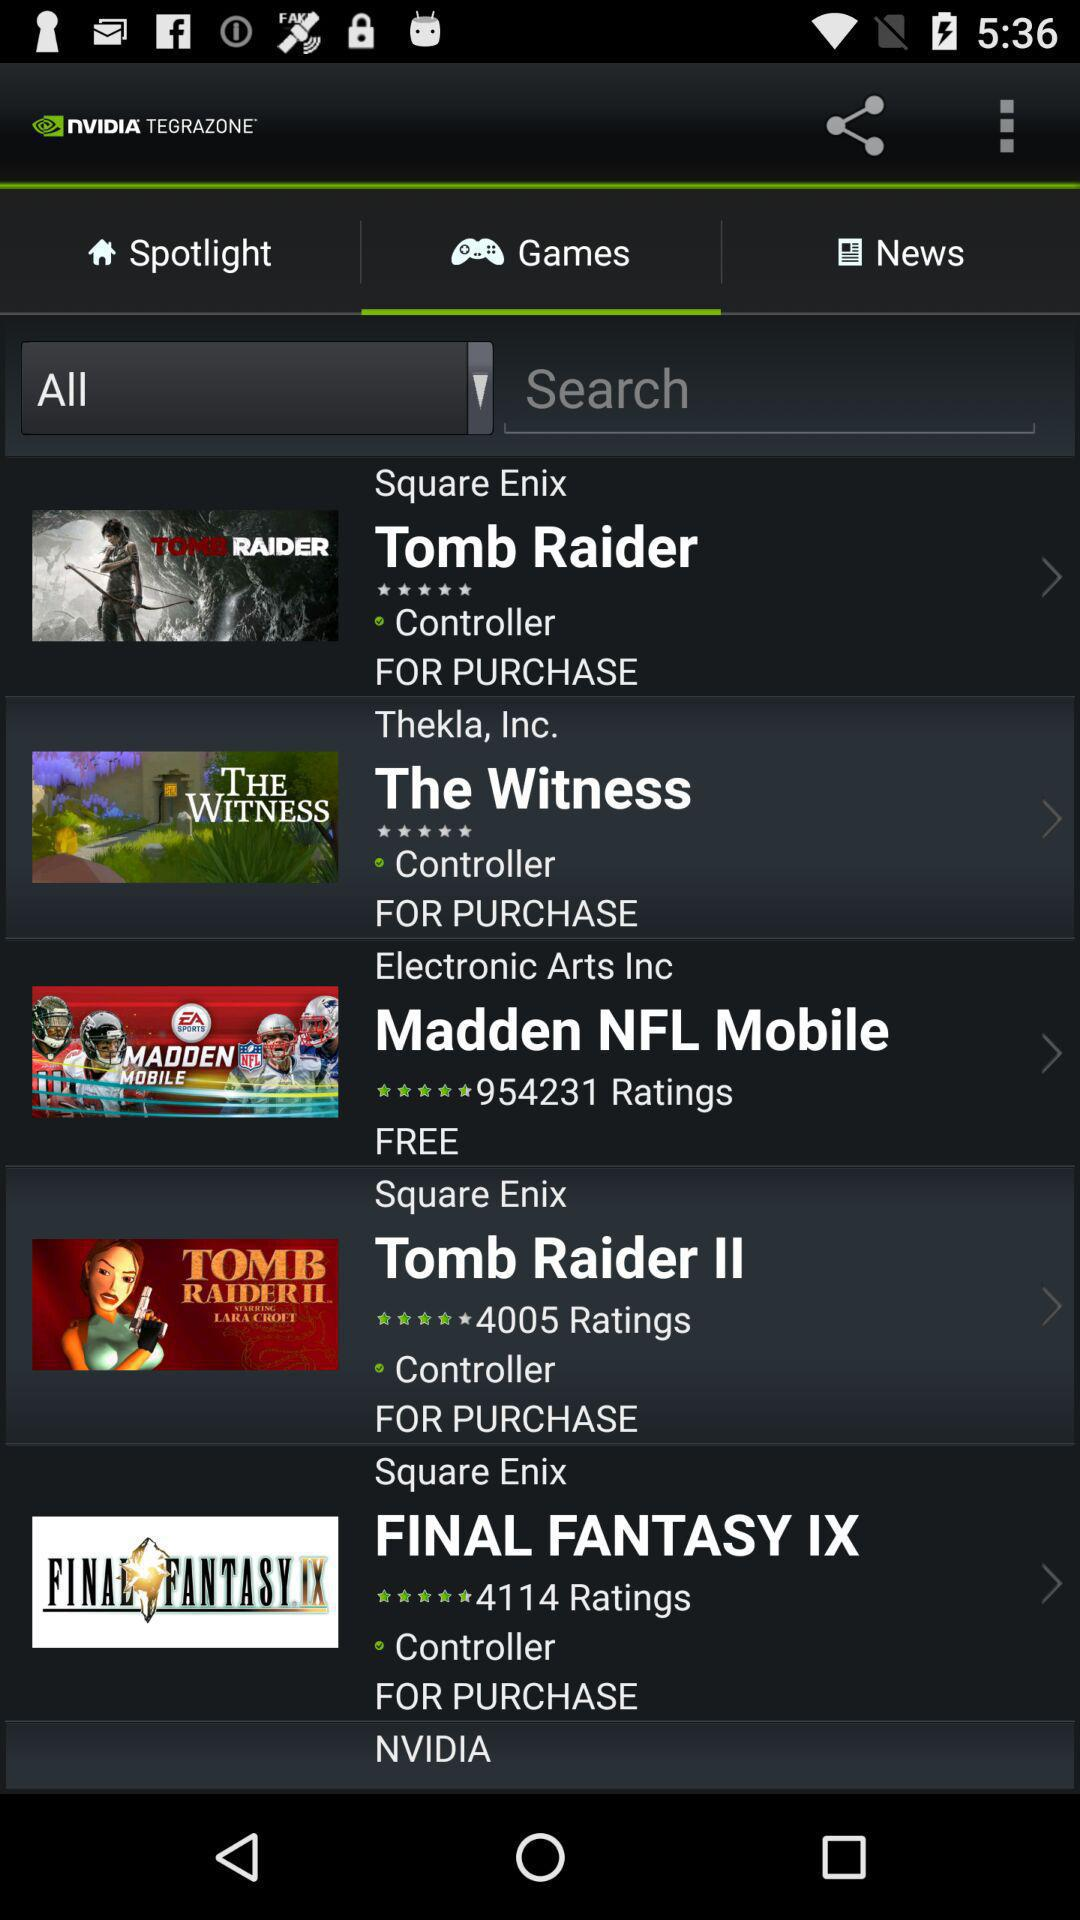Which tab is selected? The selected tab is "Games". 